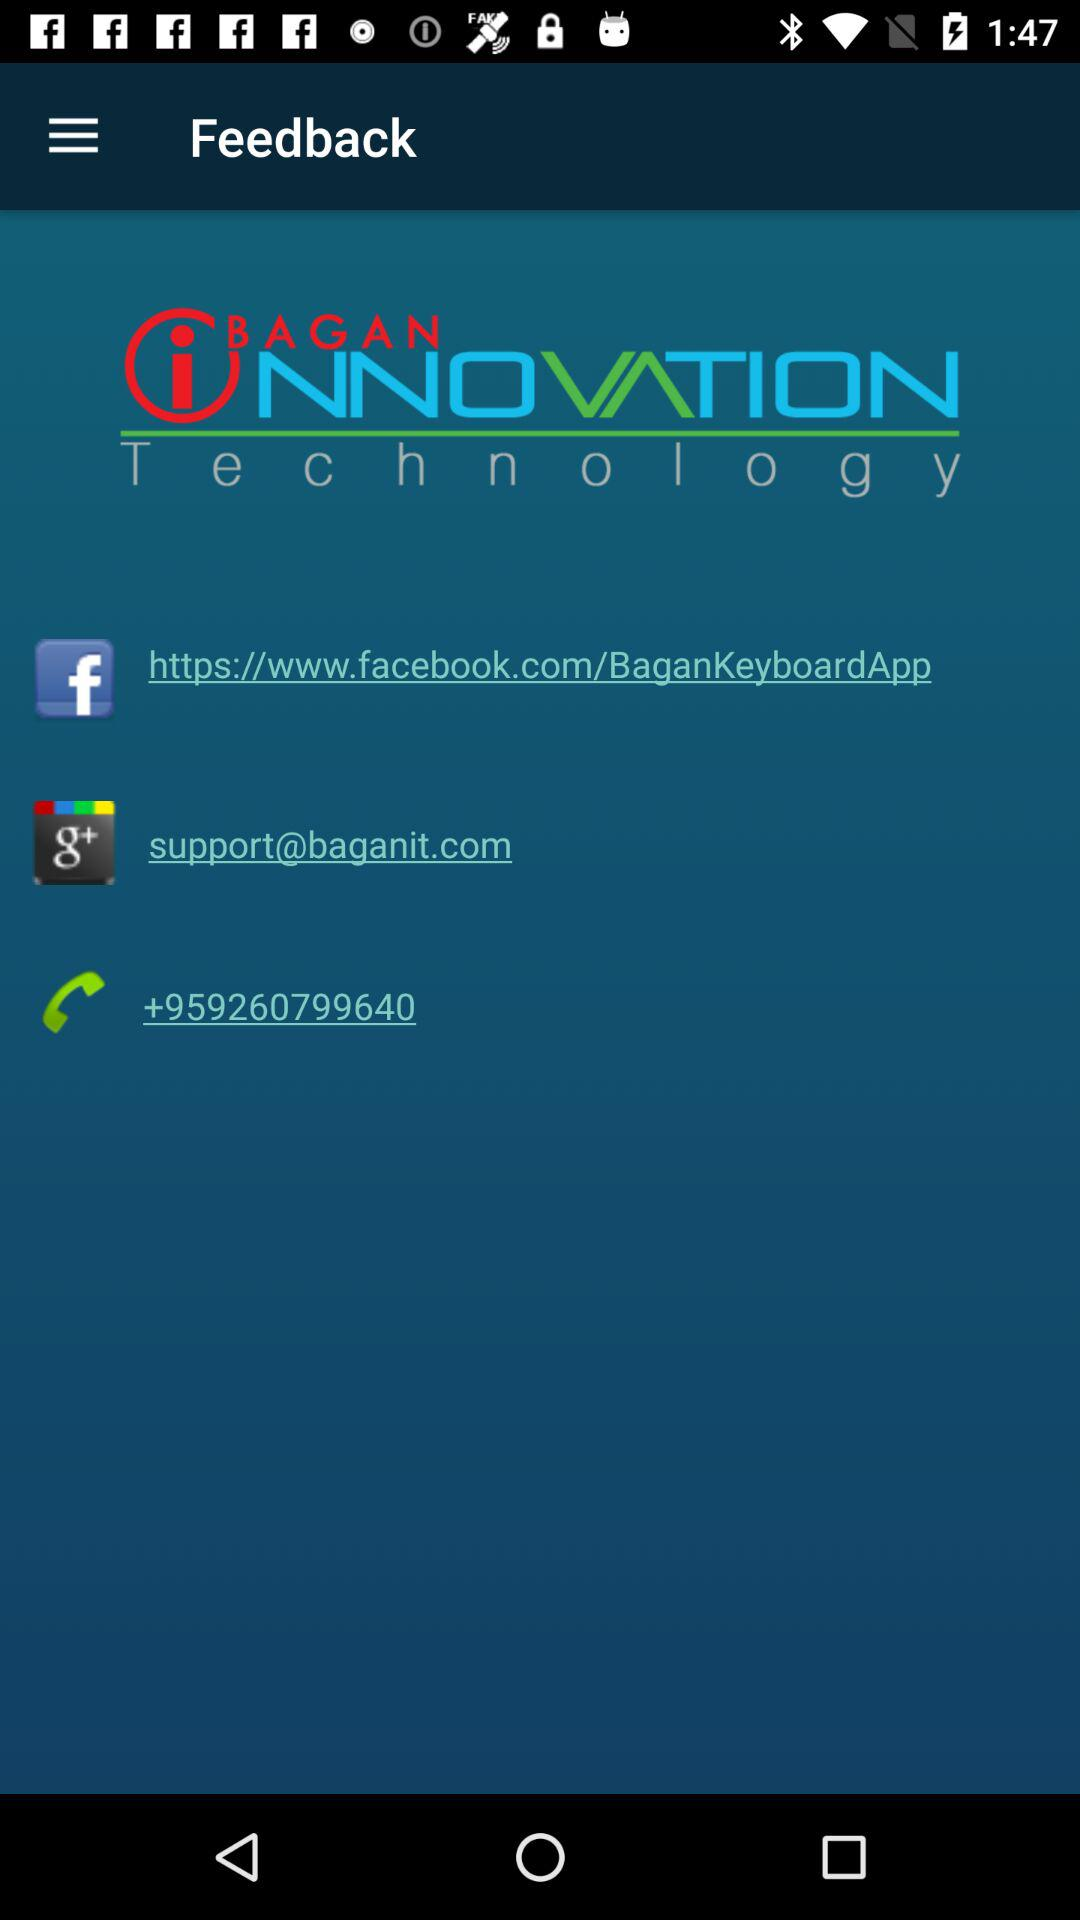What is the phone number? The phone number is +959260799640. 